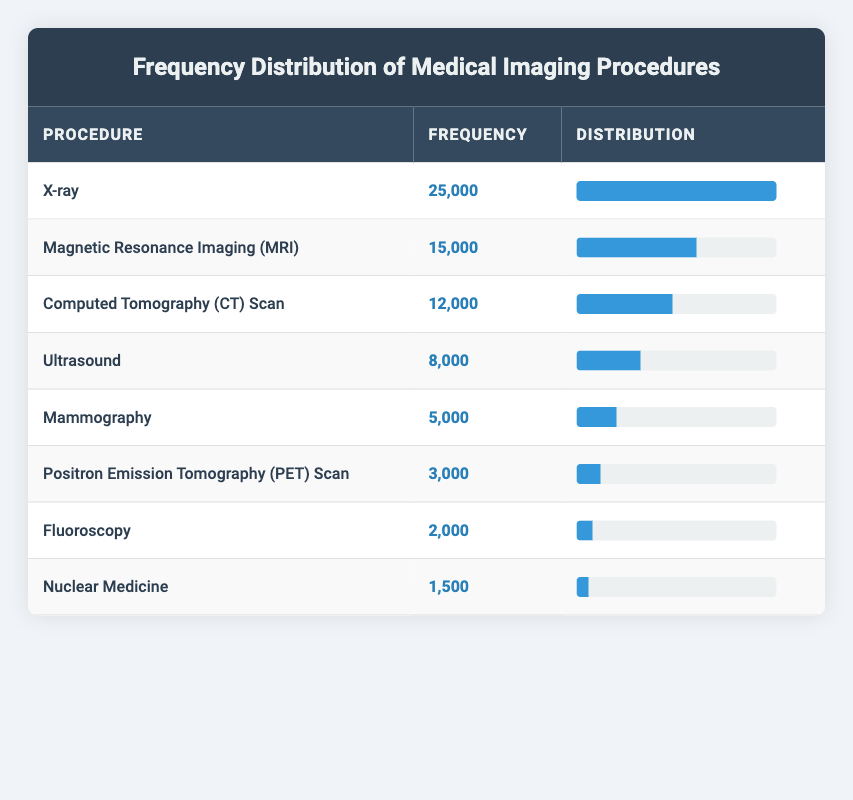What is the most common medical imaging procedure? By examining the frequency values in the table, we can see that the procedure with the highest frequency is "X-ray," which has a frequency of 25000.
Answer: X-ray How many more MRIs are conducted compared to Nuclear Medicine procedures? The frequency of Magnetic Resonance Imaging (MRI) is 15000, while the frequency of Nuclear Medicine is 1500. The difference is 15000 - 1500 = 13500.
Answer: 13500 Is the frequency of Mammography above 5000? According to the table, the frequency of Mammography is exactly 5000, so it is not above 5000.
Answer: No What is the total number of imaging procedures conducted? To find the total, we sum up all the frequencies: 25000 + 15000 + 12000 + 8000 + 5000 + 3000 + 2000 + 1500 = 60000.
Answer: 60000 What percentage of the total procedures are X-rays? We already calculated the total number of procedures as 60000. The frequency of X-rays is 25000. To find the percentage: (25000 / 60000) * 100 = 41.67%.
Answer: 41.67% Which imaging procedure has the lowest frequency? Looking at the frequency values in the table, we can see "Nuclear Medicine" has the lowest frequency at 1500.
Answer: Nuclear Medicine How many procedures have frequencies below 8000? The procedures with frequencies below 8000 are Ultrasound (8000), Mammography (5000), Positron Emission Tomography (PET) Scan (3000), Fluoroscopy (2000), and Nuclear Medicine (1500). That makes it a total of 5 procedures.
Answer: 5 Is the frequency of Ultrasound less than the average frequency of all procedures? We calculate the average by dividing the total frequency (60000) by the number of procedures (8): 60000 / 8 = 7500. The frequency of Ultrasound is 8000, which is greater than 7500.
Answer: No How does the frequency of CT Scans compare to the combined total of PET Scans and Fluoroscopy? The frequency of CT Scans is 12000. The combined frequency of PET Scans (3000) and Fluoroscopy (2000) is 3000 + 2000 = 5000. Since 12000 is greater than 5000, CT Scans have a higher frequency.
Answer: Higher 